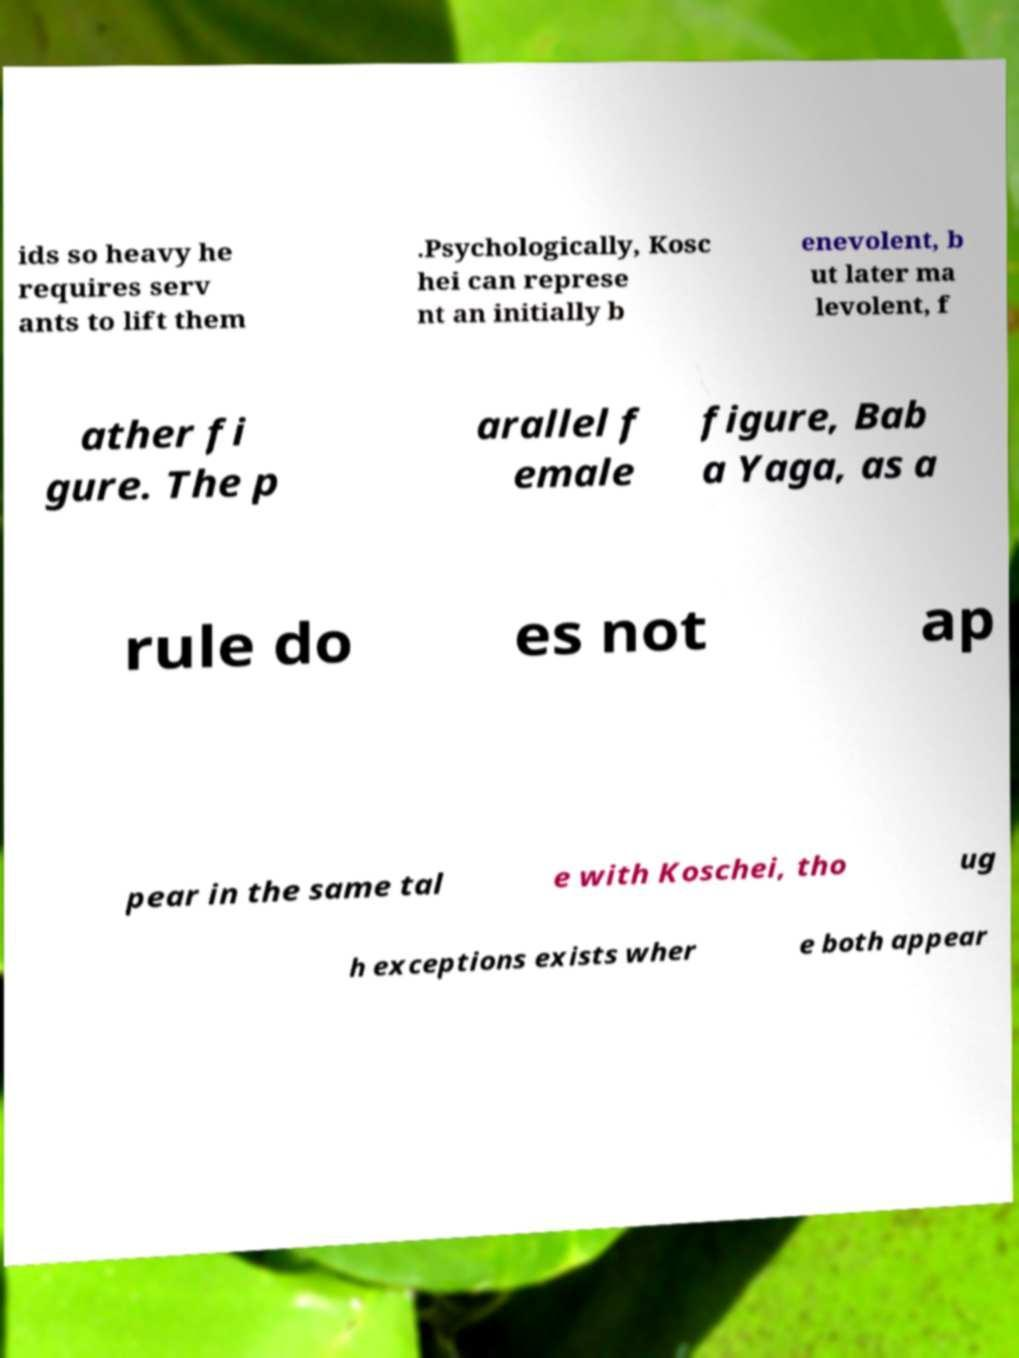What messages or text are displayed in this image? I need them in a readable, typed format. ids so heavy he requires serv ants to lift them .Psychologically, Kosc hei can represe nt an initially b enevolent, b ut later ma levolent, f ather fi gure. The p arallel f emale figure, Bab a Yaga, as a rule do es not ap pear in the same tal e with Koschei, tho ug h exceptions exists wher e both appear 